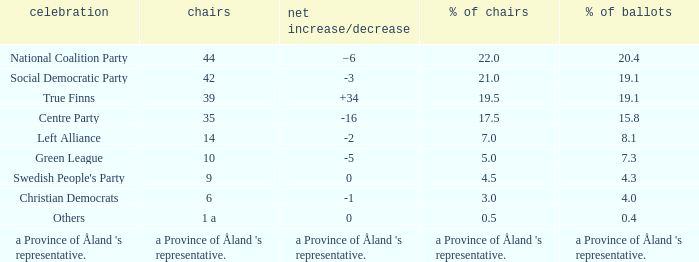When the Swedish People's Party had a net gain/loss of 0, how many seats did they have? 9.0. 